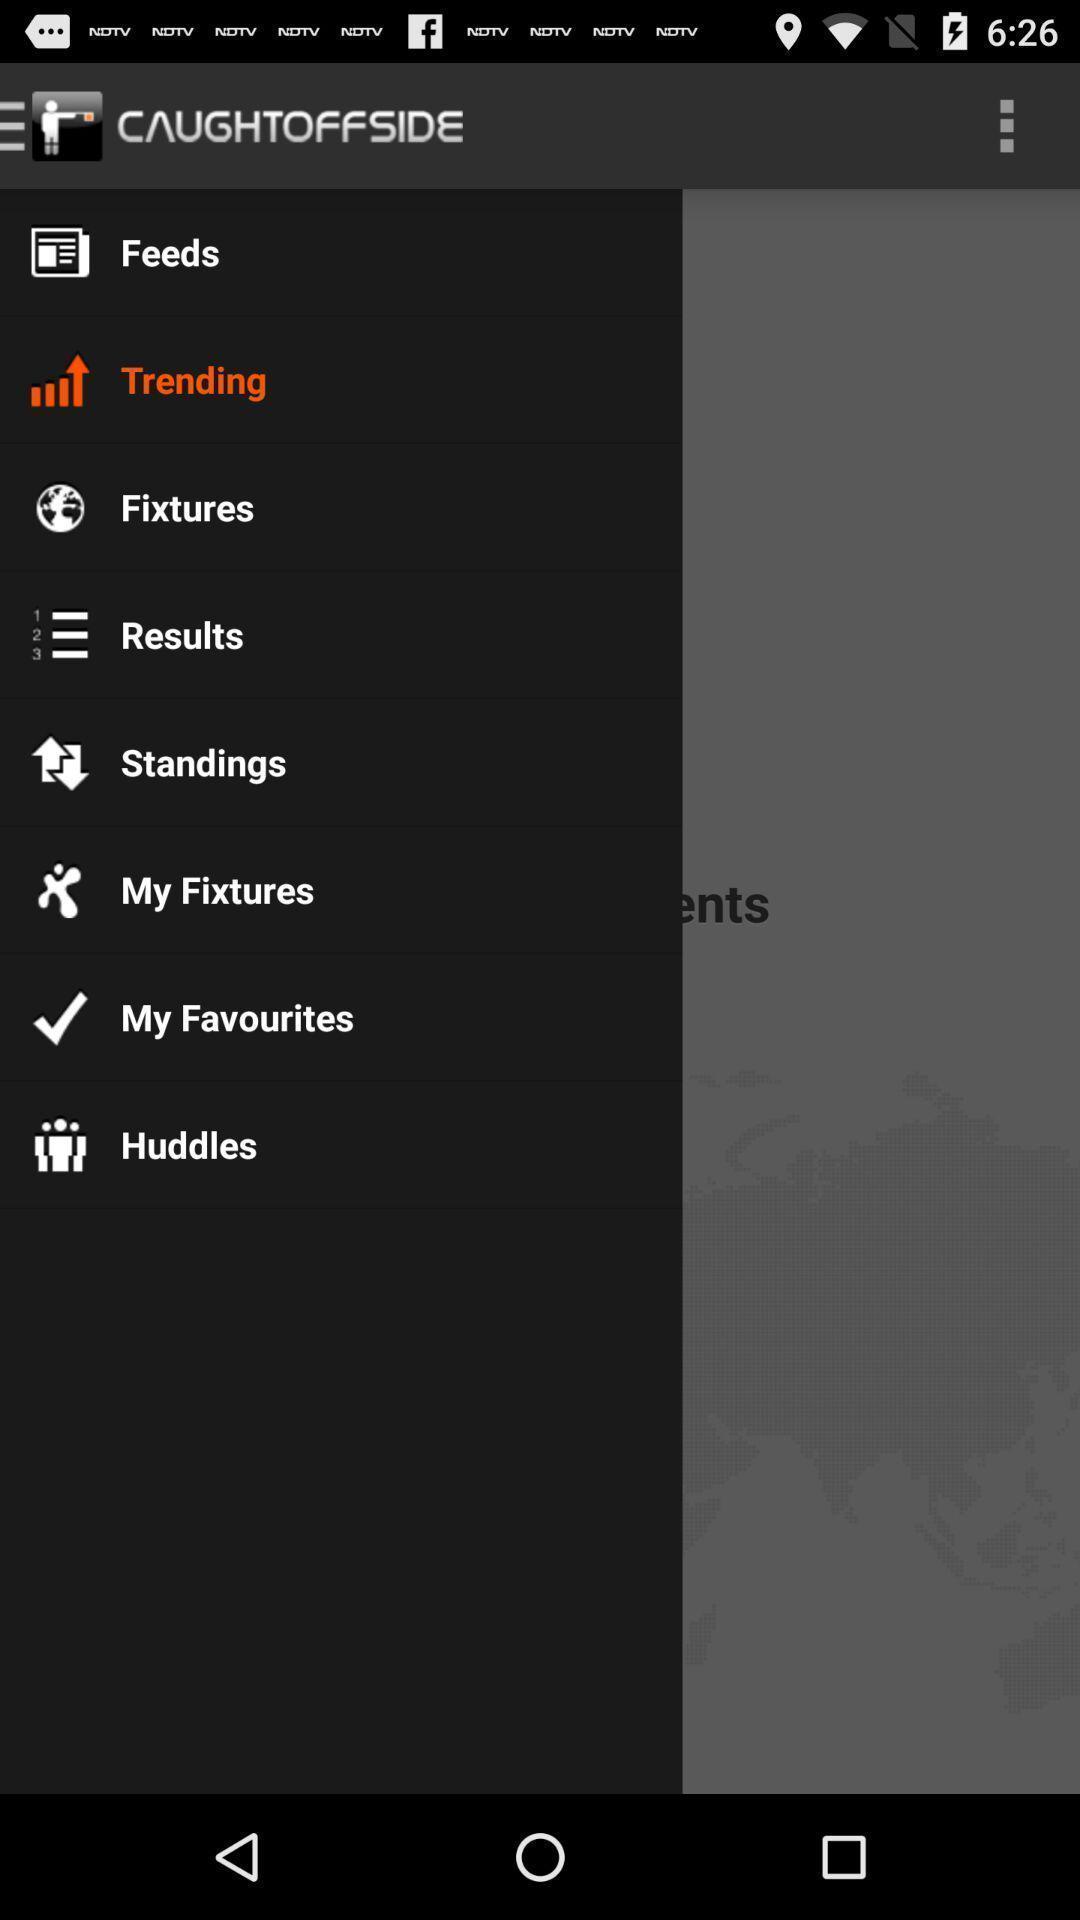Give me a narrative description of this picture. Pop up showing various options for sports application. 